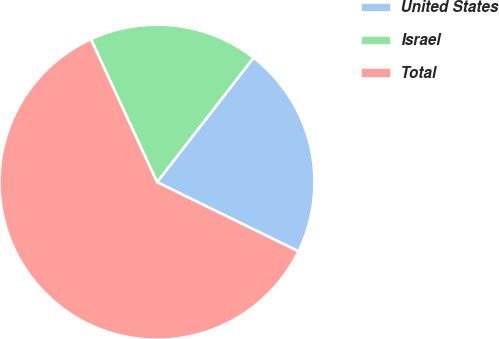<chart> <loc_0><loc_0><loc_500><loc_500><pie_chart><fcel>United States<fcel>Israel<fcel>Total<nl><fcel>21.74%<fcel>17.39%<fcel>60.87%<nl></chart> 